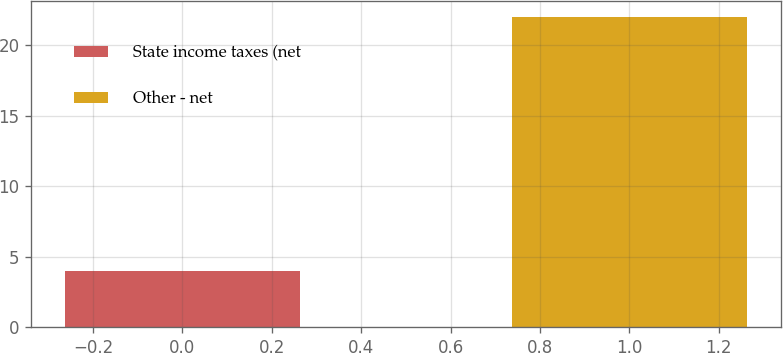<chart> <loc_0><loc_0><loc_500><loc_500><bar_chart><fcel>State income taxes (net<fcel>Other - net<nl><fcel>4<fcel>22<nl></chart> 